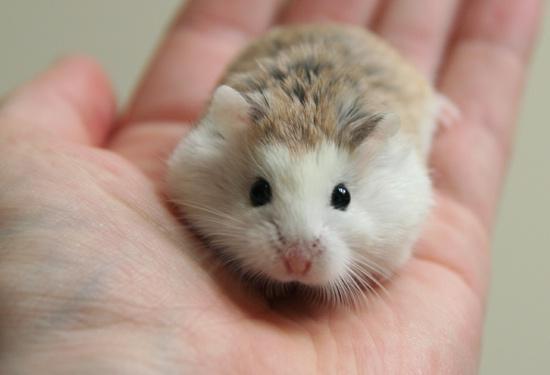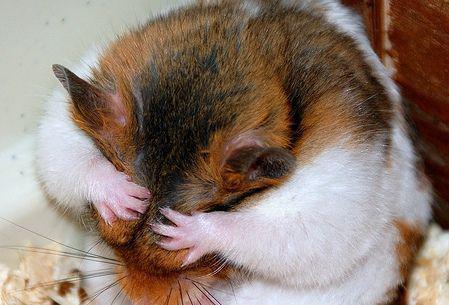The first image is the image on the left, the second image is the image on the right. For the images shown, is this caption "One outstretched palm holds a hamster that is standing and looking toward the camera." true? Answer yes or no. Yes. The first image is the image on the left, the second image is the image on the right. For the images shown, is this caption "A human hand is holding a hamster in at least one of the images." true? Answer yes or no. Yes. 